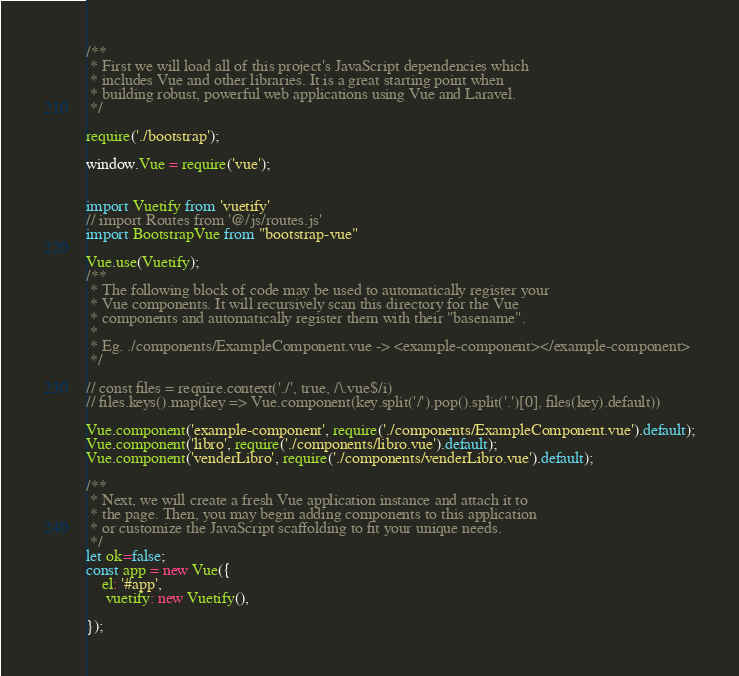Convert code to text. <code><loc_0><loc_0><loc_500><loc_500><_JavaScript_>/**
 * First we will load all of this project's JavaScript dependencies which
 * includes Vue and other libraries. It is a great starting point when
 * building robust, powerful web applications using Vue and Laravel.
 */

require('./bootstrap');

window.Vue = require('vue');


import Vuetify from 'vuetify'
// import Routes from '@/js/routes.js'
import BootstrapVue from "bootstrap-vue"

Vue.use(Vuetify);
/**
 * The following block of code may be used to automatically register your
 * Vue components. It will recursively scan this directory for the Vue
 * components and automatically register them with their "basename".
 *
 * Eg. ./components/ExampleComponent.vue -> <example-component></example-component>
 */

// const files = require.context('./', true, /\.vue$/i)
// files.keys().map(key => Vue.component(key.split('/').pop().split('.')[0], files(key).default))

Vue.component('example-component', require('./components/ExampleComponent.vue').default);
Vue.component('libro', require('./components/libro.vue').default);
Vue.component('venderLibro', require('./components/venderLibro.vue').default);

/**
 * Next, we will create a fresh Vue application instance and attach it to
 * the page. Then, you may begin adding components to this application
 * or customize the JavaScript scaffolding to fit your unique needs.
 */
let ok=false;
const app = new Vue({
    el: '#app',
     vuetify: new Vuetify(),

});
</code> 